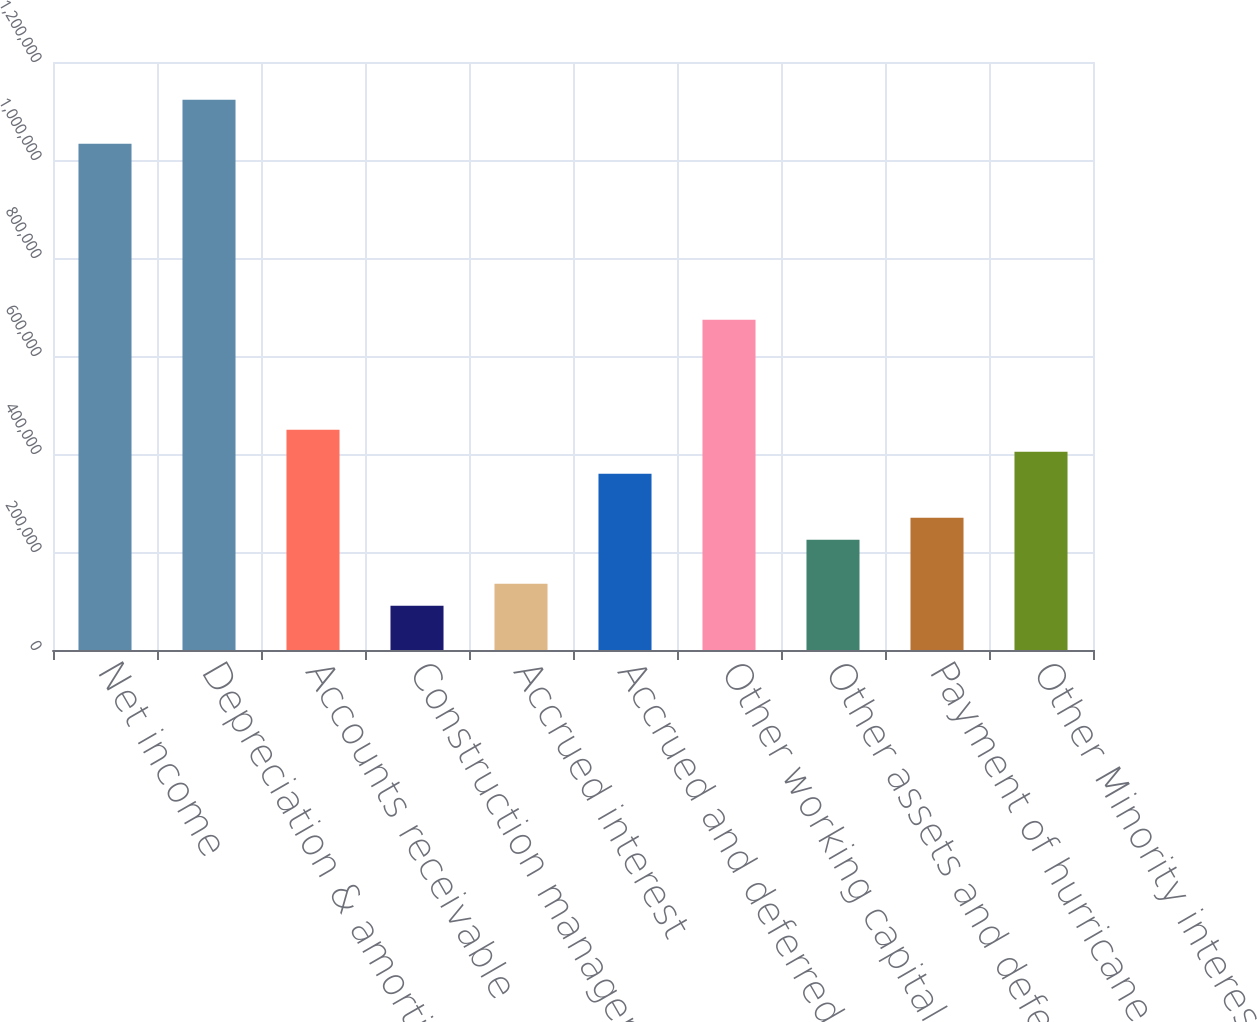<chart> <loc_0><loc_0><loc_500><loc_500><bar_chart><fcel>Net income<fcel>Depreciation & amortization<fcel>Accounts receivable<fcel>Construction management and<fcel>Accrued interest<fcel>Accrued and deferred income<fcel>Other working capital accounts<fcel>Other assets and deferred<fcel>Payment of hurricane related<fcel>Other Minority interest in<nl><fcel>1.0332e+06<fcel>1.12299e+06<fcel>449549<fcel>90380.2<fcel>135276<fcel>359757<fcel>674030<fcel>225068<fcel>269965<fcel>404653<nl></chart> 